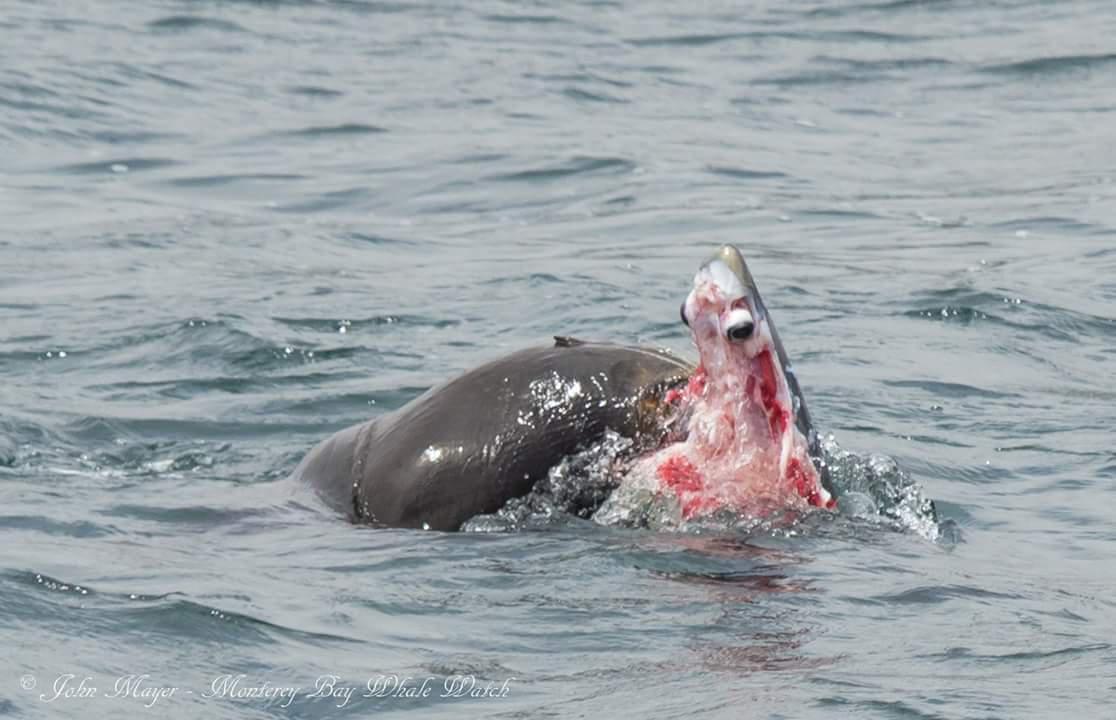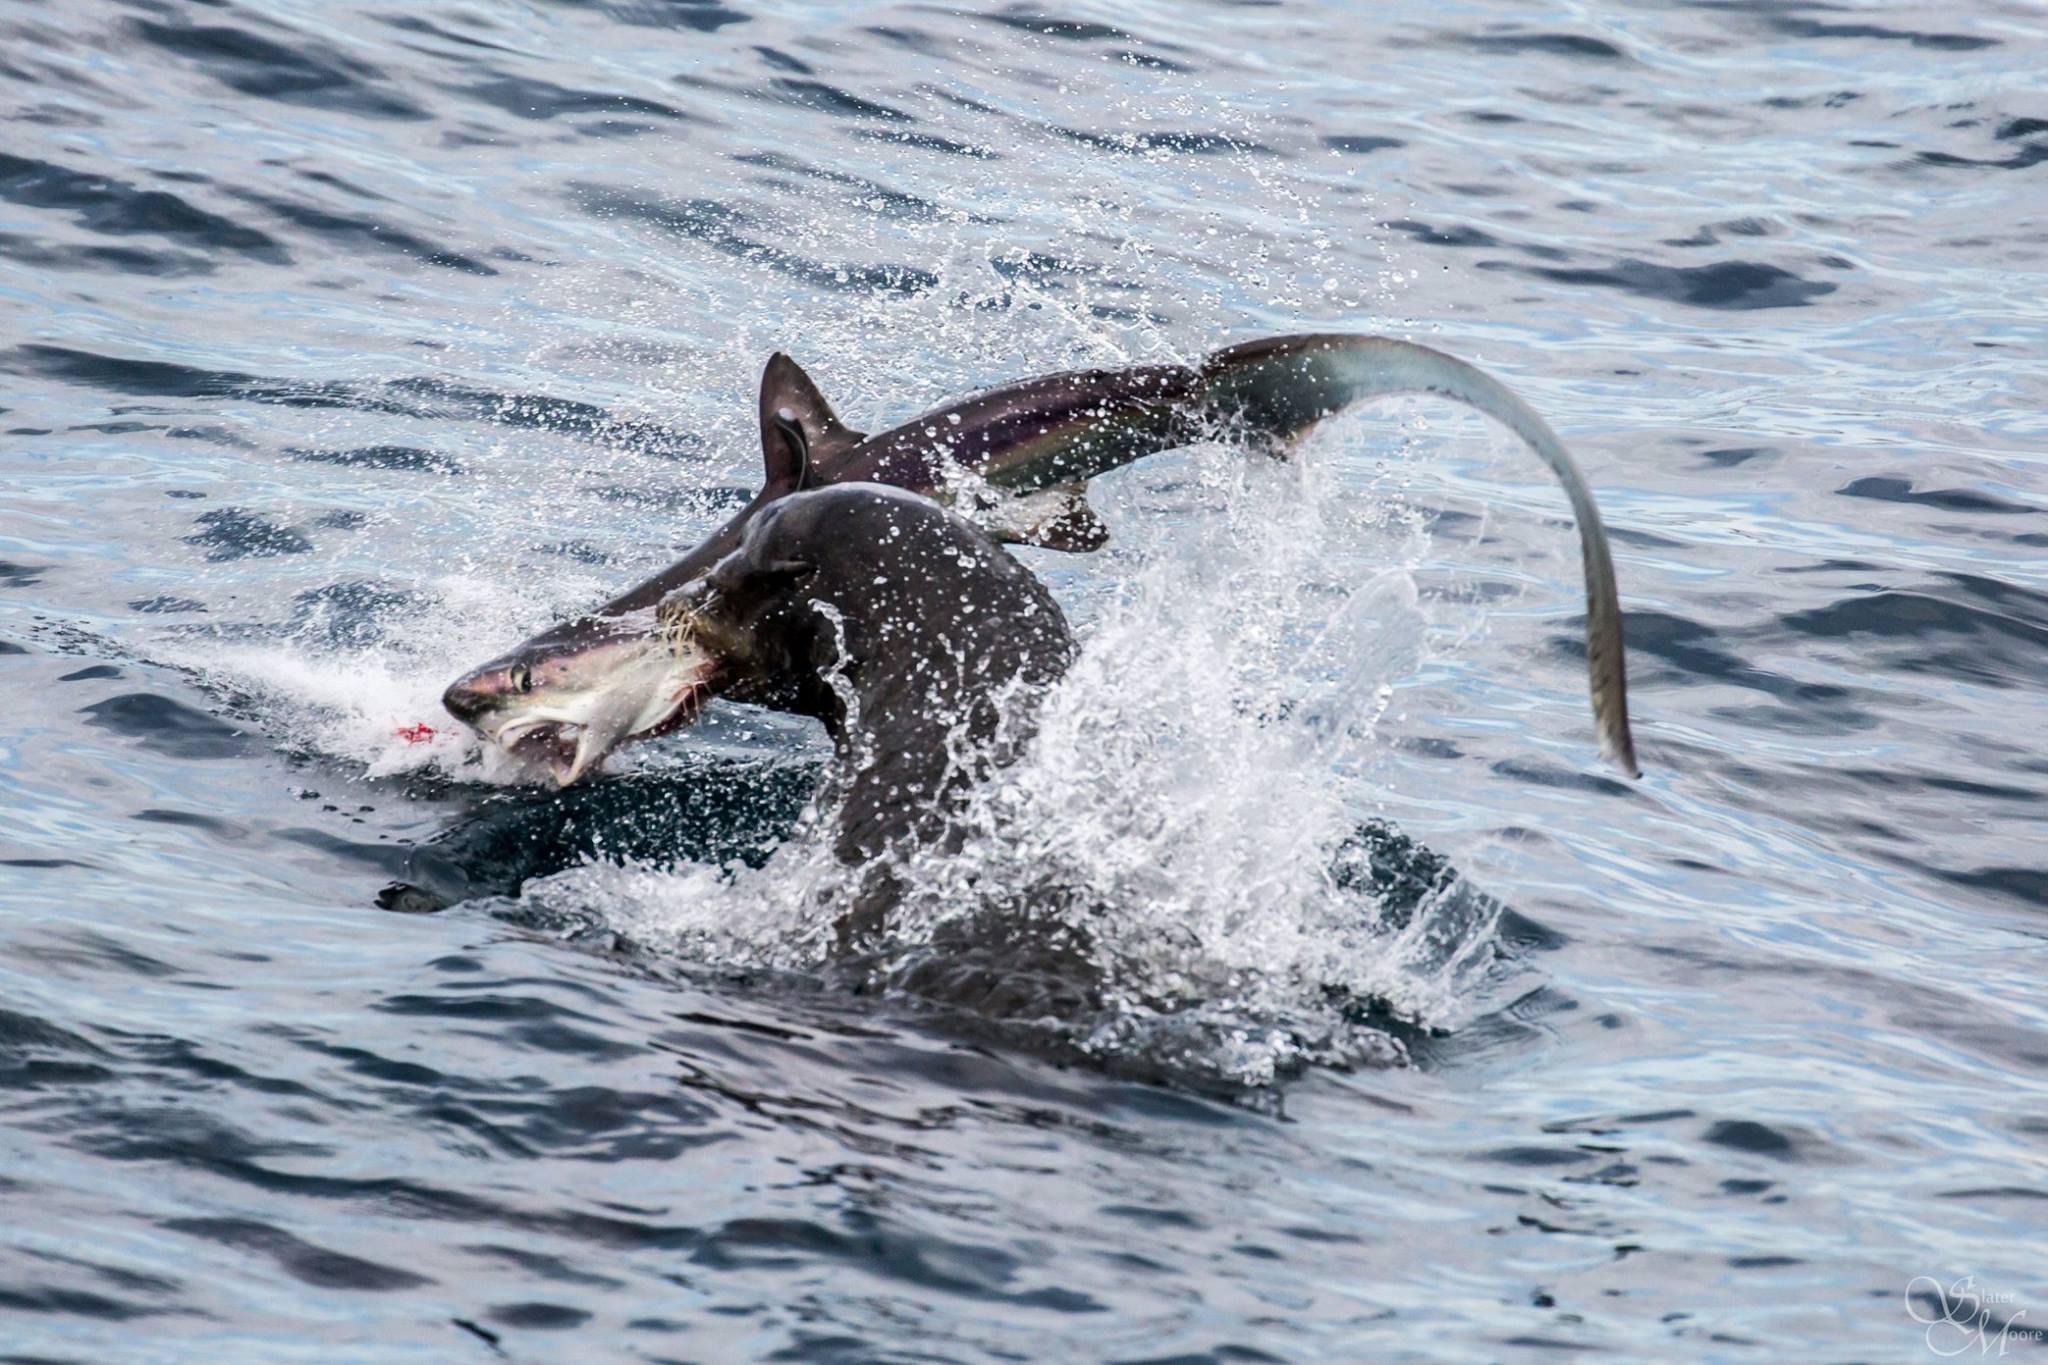The first image is the image on the left, the second image is the image on the right. Evaluate the accuracy of this statement regarding the images: "The seal in the left image is facing left with food in its mouth.". Is it true? Answer yes or no. No. The first image is the image on the left, the second image is the image on the right. For the images displayed, is the sentence "All of the images contains only animals and water and nothing else." factually correct? Answer yes or no. Yes. 